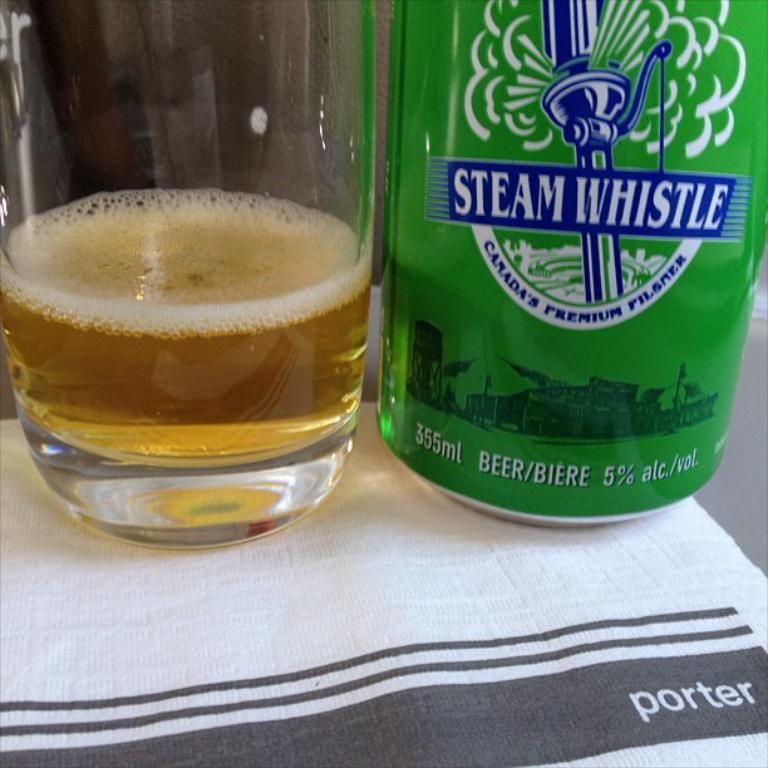Provide a one-sentence caption for the provided image. A green bottle of Steam Whistle has a volume of 355 mL. 